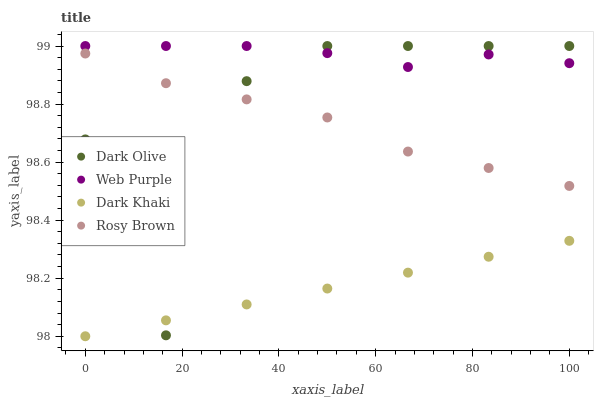Does Dark Khaki have the minimum area under the curve?
Answer yes or no. Yes. Does Web Purple have the maximum area under the curve?
Answer yes or no. Yes. Does Dark Olive have the minimum area under the curve?
Answer yes or no. No. Does Dark Olive have the maximum area under the curve?
Answer yes or no. No. Is Dark Khaki the smoothest?
Answer yes or no. Yes. Is Dark Olive the roughest?
Answer yes or no. Yes. Is Web Purple the smoothest?
Answer yes or no. No. Is Web Purple the roughest?
Answer yes or no. No. Does Dark Khaki have the lowest value?
Answer yes or no. Yes. Does Dark Olive have the lowest value?
Answer yes or no. No. Does Dark Olive have the highest value?
Answer yes or no. Yes. Does Rosy Brown have the highest value?
Answer yes or no. No. Is Dark Khaki less than Web Purple?
Answer yes or no. Yes. Is Web Purple greater than Rosy Brown?
Answer yes or no. Yes. Does Dark Olive intersect Web Purple?
Answer yes or no. Yes. Is Dark Olive less than Web Purple?
Answer yes or no. No. Is Dark Olive greater than Web Purple?
Answer yes or no. No. Does Dark Khaki intersect Web Purple?
Answer yes or no. No. 